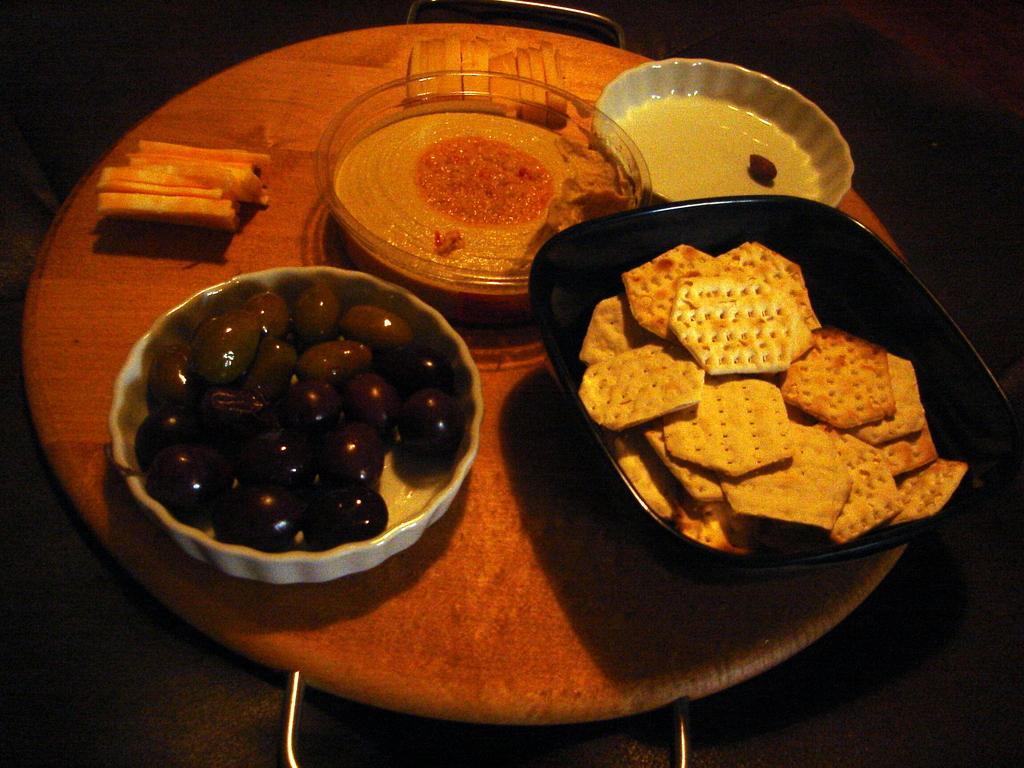In one or two sentences, can you explain what this image depicts? In this picture we can see some bowls on it some eatable this is placed on the table. 